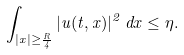<formula> <loc_0><loc_0><loc_500><loc_500>\int _ { | x | \geq \frac { R } { 4 } } | u ( t , x ) | ^ { 2 } \, d x \leq \eta .</formula> 